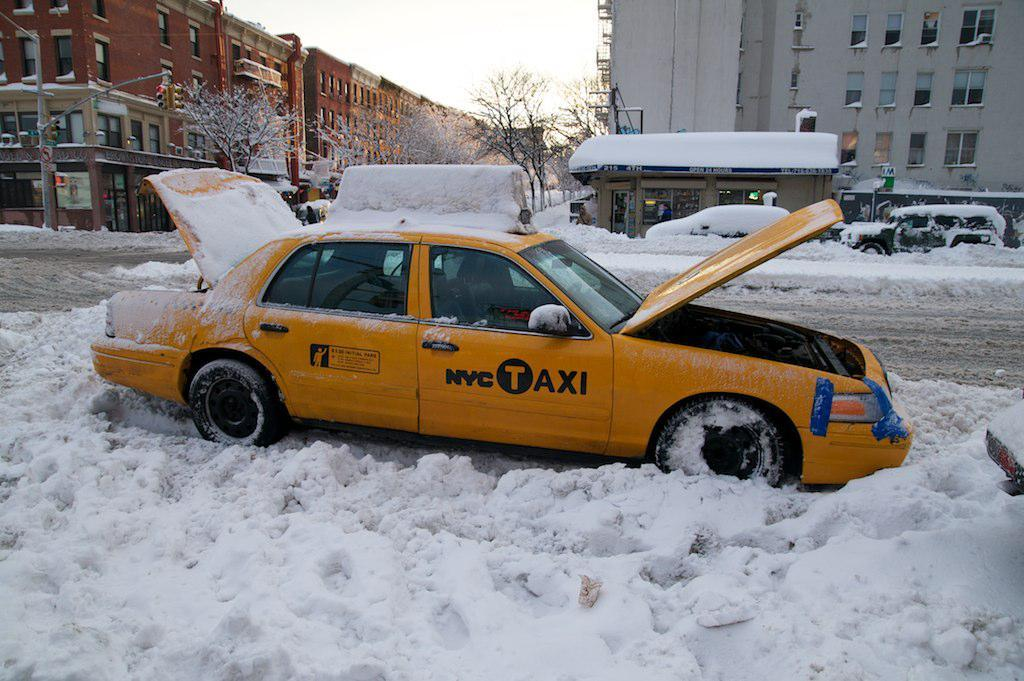<image>
Describe the image concisely. The yellow taxi here is from New York City 